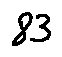<formula> <loc_0><loc_0><loc_500><loc_500>8 3</formula> 